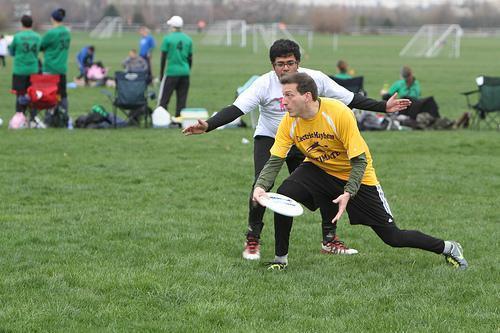How many people playing frisbee?
Give a very brief answer. 2. 